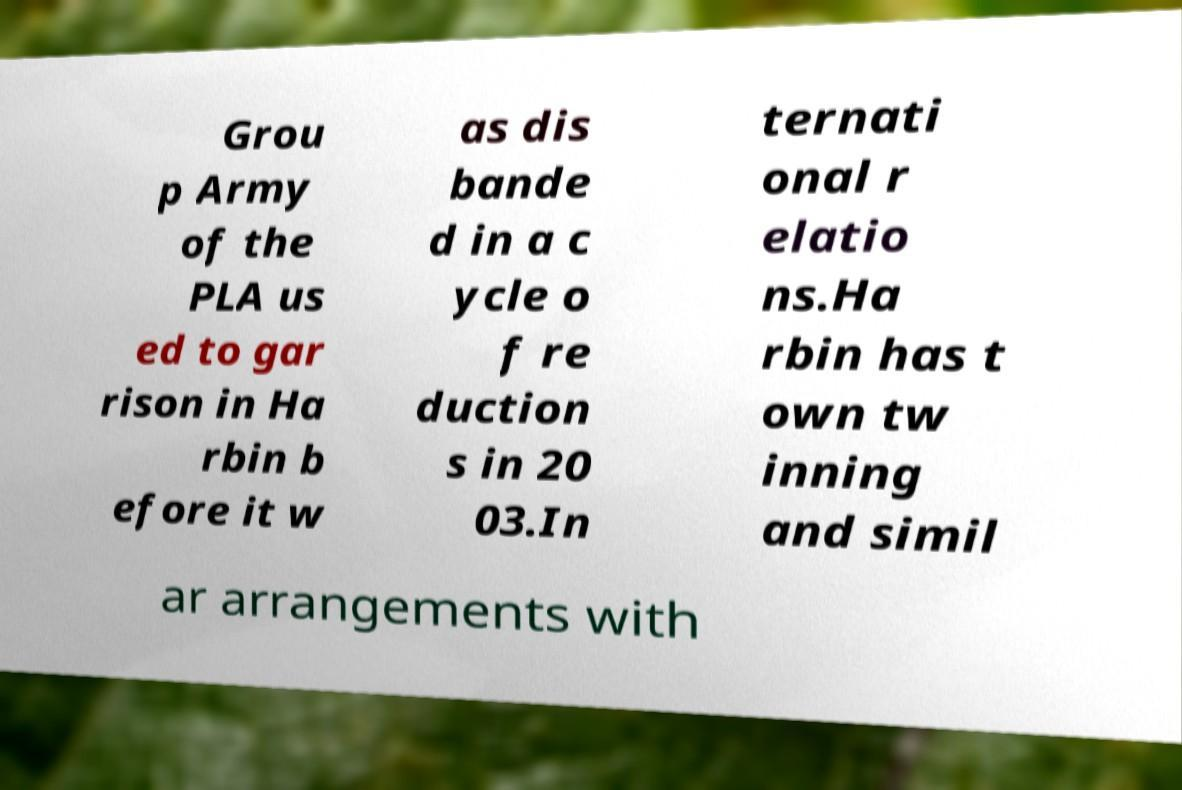Could you extract and type out the text from this image? Grou p Army of the PLA us ed to gar rison in Ha rbin b efore it w as dis bande d in a c ycle o f re duction s in 20 03.In ternati onal r elatio ns.Ha rbin has t own tw inning and simil ar arrangements with 